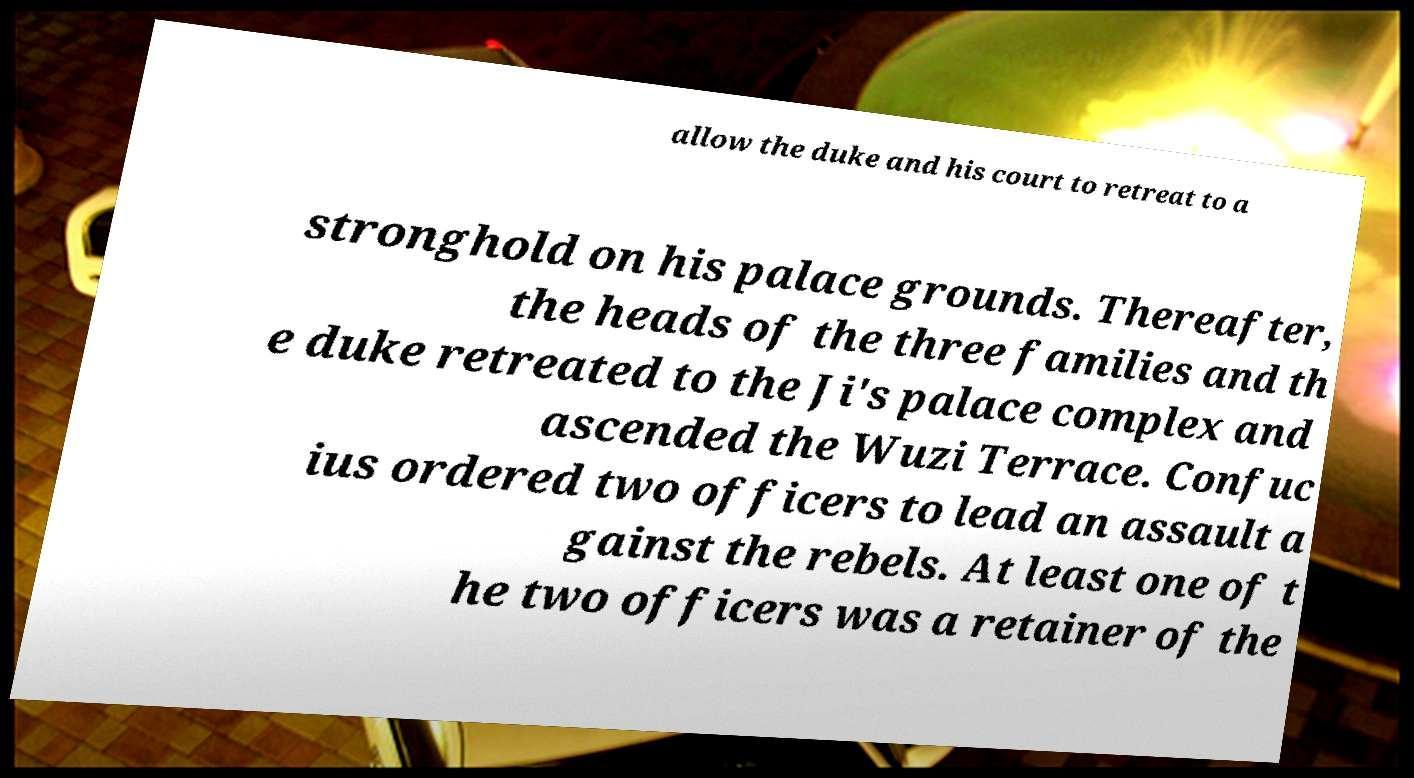Please identify and transcribe the text found in this image. allow the duke and his court to retreat to a stronghold on his palace grounds. Thereafter, the heads of the three families and th e duke retreated to the Ji's palace complex and ascended the Wuzi Terrace. Confuc ius ordered two officers to lead an assault a gainst the rebels. At least one of t he two officers was a retainer of the 